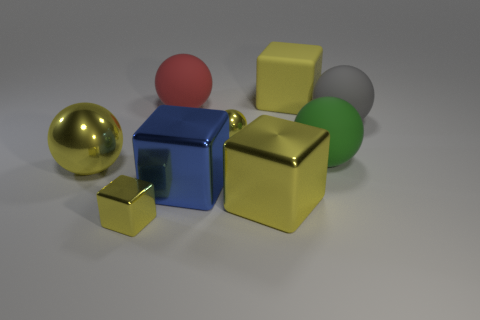Does the blue shiny block have the same size as the cube that is left of the blue metal cube?
Offer a very short reply. No. There is another large metal object that is the same shape as the green object; what color is it?
Make the answer very short. Yellow. What number of other things are there of the same size as the red matte object?
Give a very brief answer. 6. How many objects are large rubber things on the left side of the big gray rubber ball or yellow objects that are to the left of the red rubber thing?
Provide a succinct answer. 5. The green thing that is the same size as the blue block is what shape?
Your response must be concise. Sphere. There is another yellow block that is made of the same material as the tiny yellow block; what size is it?
Make the answer very short. Large. Is the shape of the large gray matte thing the same as the big green thing?
Provide a succinct answer. Yes. What color is the rubber block that is the same size as the red object?
Offer a terse response. Yellow. What size is the green rubber thing that is the same shape as the gray rubber object?
Offer a very short reply. Large. What shape is the large matte thing in front of the large gray matte sphere?
Provide a short and direct response. Sphere. 